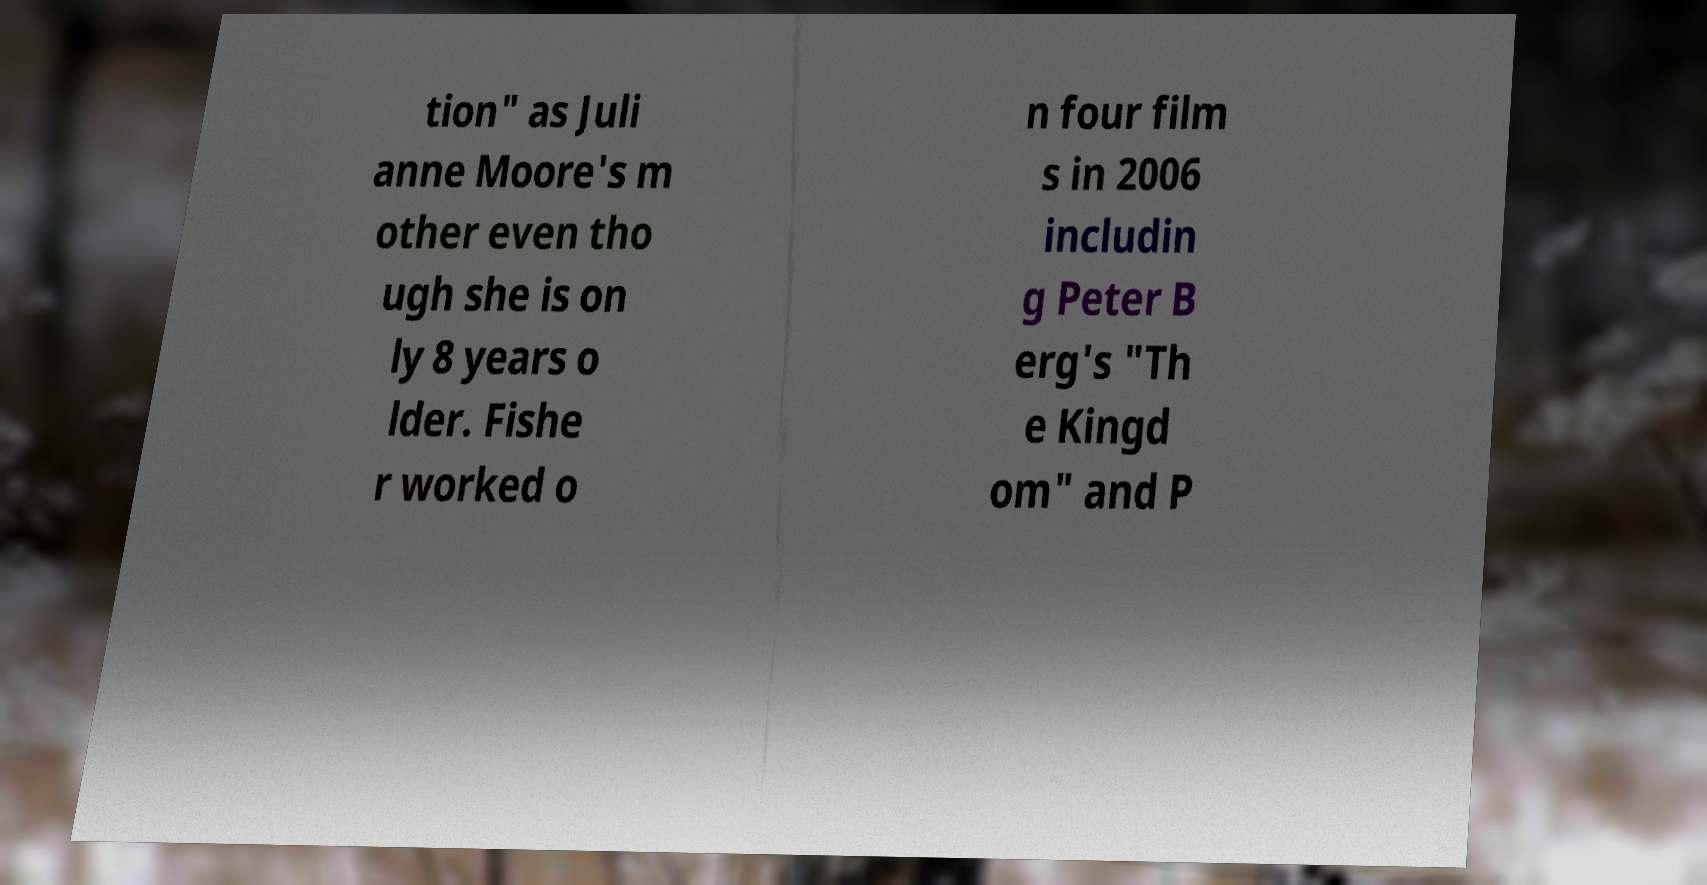Can you read and provide the text displayed in the image?This photo seems to have some interesting text. Can you extract and type it out for me? tion" as Juli anne Moore's m other even tho ugh she is on ly 8 years o lder. Fishe r worked o n four film s in 2006 includin g Peter B erg's "Th e Kingd om" and P 